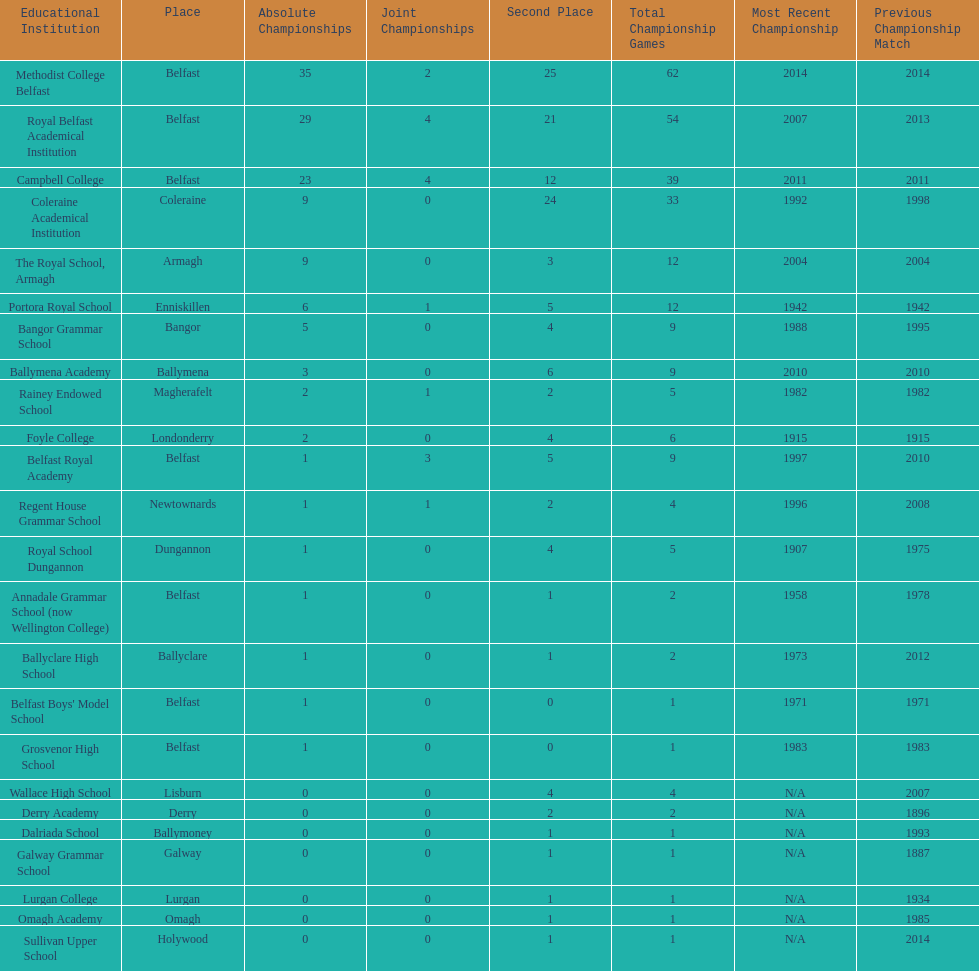Which schools have the largest number of shared titles? Royal Belfast Academical Institution, Campbell College. 